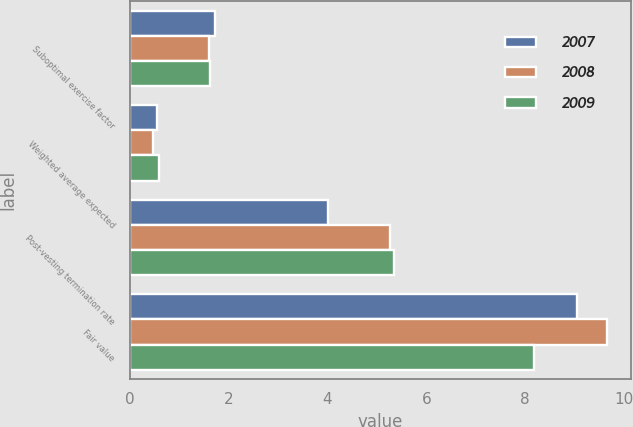Convert chart to OTSL. <chart><loc_0><loc_0><loc_500><loc_500><stacked_bar_chart><ecel><fcel>Suboptimal exercise factor<fcel>Weighted average expected<fcel>Post-vesting termination rate<fcel>Fair value<nl><fcel>2007<fcel>1.73<fcel>0.55<fcel>4.02<fcel>9.05<nl><fcel>2008<fcel>1.61<fcel>0.48<fcel>5.26<fcel>9.65<nl><fcel>2009<fcel>1.62<fcel>0.59<fcel>5.34<fcel>8.18<nl></chart> 